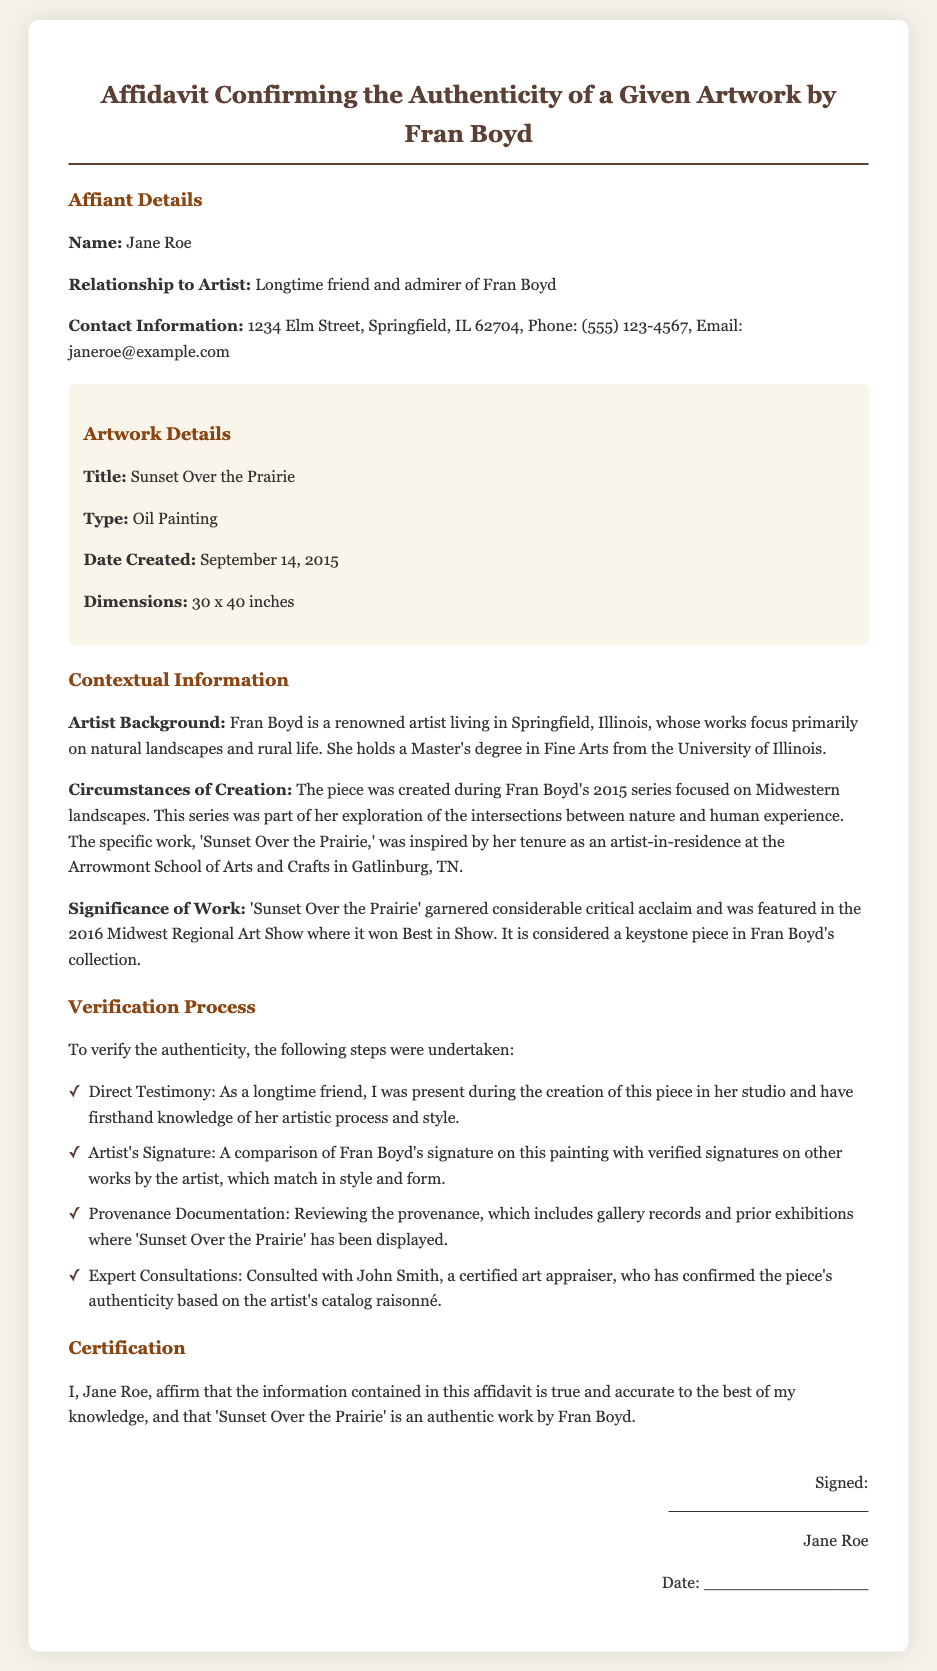What is the name of the affiant? The affiant's name is stated in the document under the Affiant Details section.
Answer: Jane Roe What is the title of the artwork? The title of the artwork is clearly listed in the Artwork Details section.
Answer: Sunset Over the Prairie When was the artwork created? The date the artwork was created can be found in the Artwork Details section.
Answer: September 14, 2015 What type of artwork is 'Sunset Over the Prairie'? The type of artwork is specified in the Artwork Details section.
Answer: Oil Painting Who confirmed the authenticity of the artwork? The person who confirmed the authenticity is mentioned in the Verification Process section.
Answer: John Smith What significant award did the artwork receive? The significance of the artwork includes specific recognition noted in the context section.
Answer: Best in Show Where did Fran Boyd create the piece? The location linked to the creation of the artwork is detailed in the Circumstances of Creation section.
Answer: Arrowmont School of Arts and Crafts What is Jane Roe's relationship to Fran Boyd? The relationship of Jane Roe to Fran Boyd is explained in the Affiant Details section.
Answer: Longtime friend and admirer How large is the artwork in inches? The dimensions of the artwork are provided in the Artwork Details section.
Answer: 30 x 40 inches 